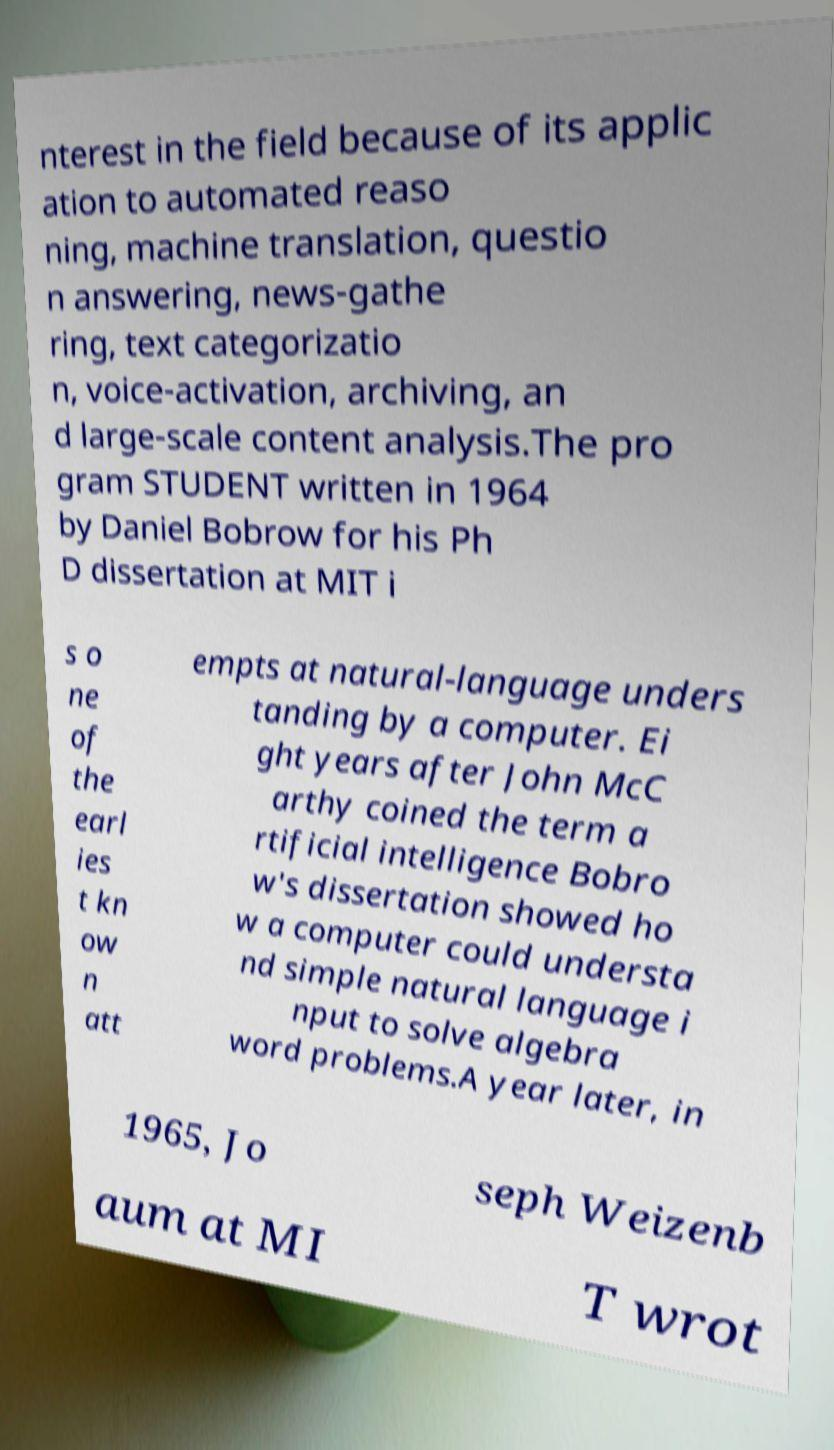Please read and relay the text visible in this image. What does it say? nterest in the field because of its applic ation to automated reaso ning, machine translation, questio n answering, news-gathe ring, text categorizatio n, voice-activation, archiving, an d large-scale content analysis.The pro gram STUDENT written in 1964 by Daniel Bobrow for his Ph D dissertation at MIT i s o ne of the earl ies t kn ow n att empts at natural-language unders tanding by a computer. Ei ght years after John McC arthy coined the term a rtificial intelligence Bobro w's dissertation showed ho w a computer could understa nd simple natural language i nput to solve algebra word problems.A year later, in 1965, Jo seph Weizenb aum at MI T wrot 